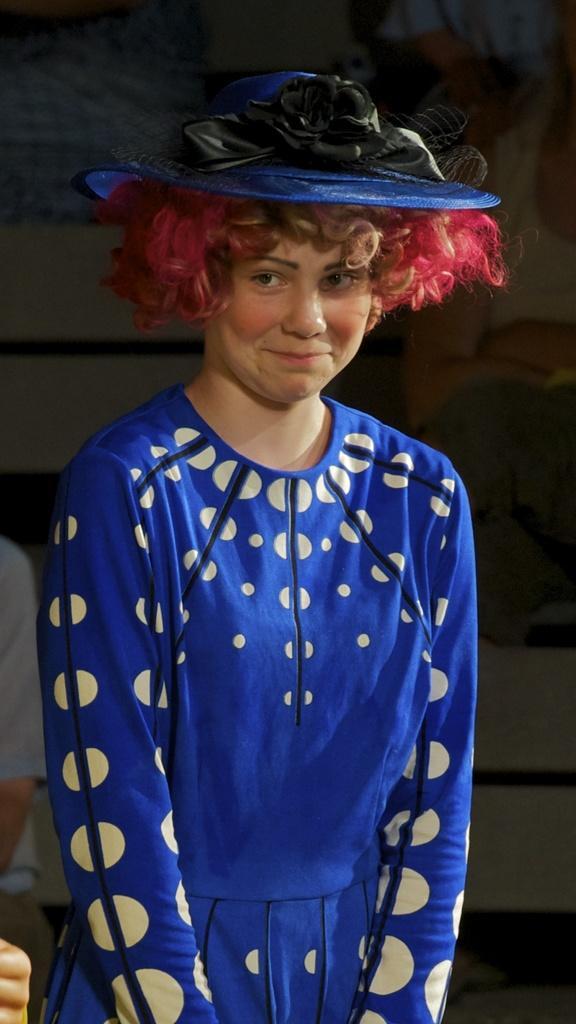Can you describe this image briefly? In this image we can see there is a girl wearing a blue dress and a blue hat is standing with a smile on her face. 